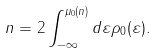Convert formula to latex. <formula><loc_0><loc_0><loc_500><loc_500>n = 2 \int _ { - \infty } ^ { \mu _ { 0 } ( n ) } d \varepsilon \rho _ { 0 } ( \varepsilon ) .</formula> 